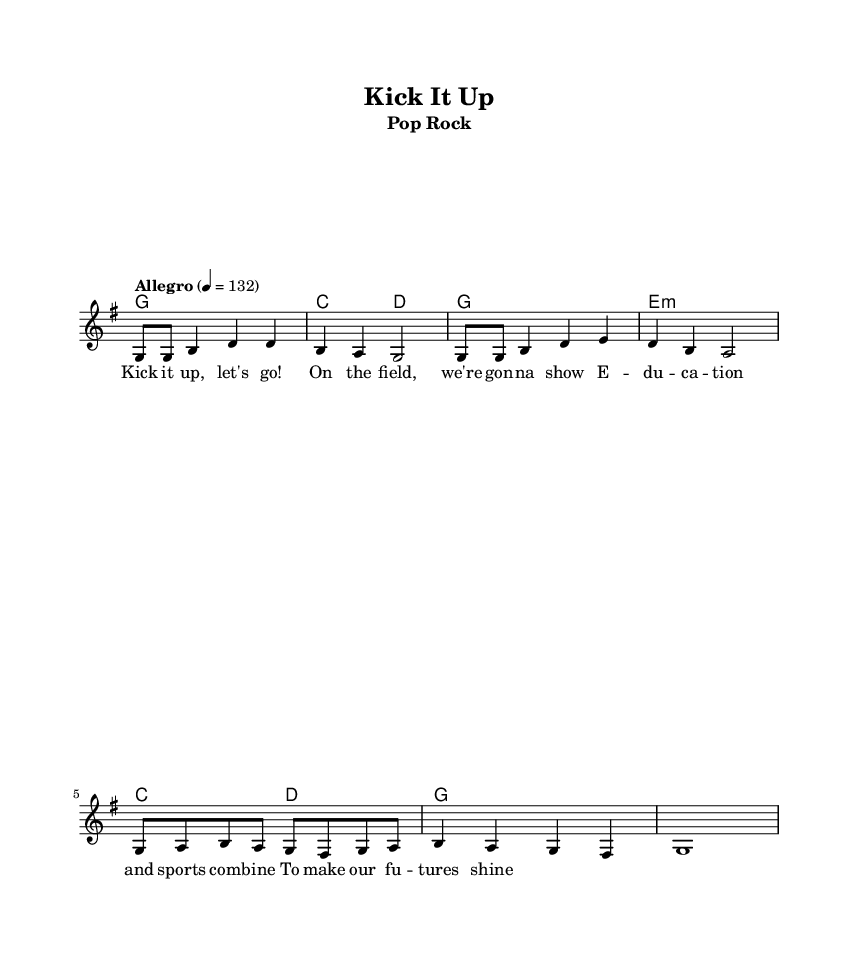What is the key signature of this music? The key signature is G major, which has one sharp (F#). You can identify this by looking at the key signature indicator at the beginning of the staff.
Answer: G major What is the time signature of this music? The time signature is 4/4, which means there are four beats per measure. You can find this at the beginning of the music staff, where it is notated right after the key signature.
Answer: 4/4 What is the tempo marking of this music? The tempo marking is Allegro, which indicates a fast pace. This is mentioned in the tempo indication, where it specifies a speed of 132 beats per minute.
Answer: Allegro How many measures are in the melody section? The melody section consists of 8 measures. You can count each measure separated by vertical lines in the sheet music, noting each grouping.
Answer: 8 What is the first note of the melody? The first note of the melody is G. This can be found by looking at the first note in the melody line of the staff.
Answer: G What is the last chord in the harmonies? The last chord is G major. You can deduce this by analyzing the harmonic progression and observing that the last chord notation shows a G chord.
Answer: G How does the lyric "Kick it up, let's go!" contribute to the theme of the song? The lyric emphasizes excitement and motivation, which aligns with the energetic soccer theme of the song. This thematic connection is drawn from the motivational context described in the lyrics, inspiring action and enthusiasm on the field.
Answer: Excitement 